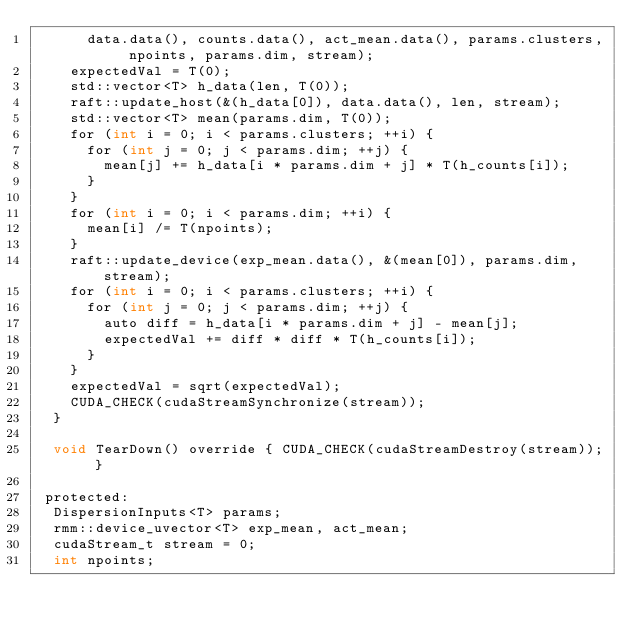Convert code to text. <code><loc_0><loc_0><loc_500><loc_500><_Cuda_>      data.data(), counts.data(), act_mean.data(), params.clusters, npoints, params.dim, stream);
    expectedVal = T(0);
    std::vector<T> h_data(len, T(0));
    raft::update_host(&(h_data[0]), data.data(), len, stream);
    std::vector<T> mean(params.dim, T(0));
    for (int i = 0; i < params.clusters; ++i) {
      for (int j = 0; j < params.dim; ++j) {
        mean[j] += h_data[i * params.dim + j] * T(h_counts[i]);
      }
    }
    for (int i = 0; i < params.dim; ++i) {
      mean[i] /= T(npoints);
    }
    raft::update_device(exp_mean.data(), &(mean[0]), params.dim, stream);
    for (int i = 0; i < params.clusters; ++i) {
      for (int j = 0; j < params.dim; ++j) {
        auto diff = h_data[i * params.dim + j] - mean[j];
        expectedVal += diff * diff * T(h_counts[i]);
      }
    }
    expectedVal = sqrt(expectedVal);
    CUDA_CHECK(cudaStreamSynchronize(stream));
  }

  void TearDown() override { CUDA_CHECK(cudaStreamDestroy(stream)); }

 protected:
  DispersionInputs<T> params;
  rmm::device_uvector<T> exp_mean, act_mean;
  cudaStream_t stream = 0;
  int npoints;</code> 